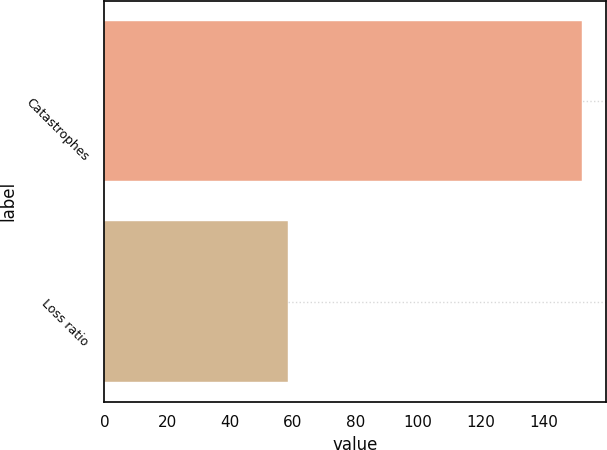Convert chart. <chart><loc_0><loc_0><loc_500><loc_500><bar_chart><fcel>Catastrophes<fcel>Loss ratio<nl><fcel>152.3<fcel>58.6<nl></chart> 